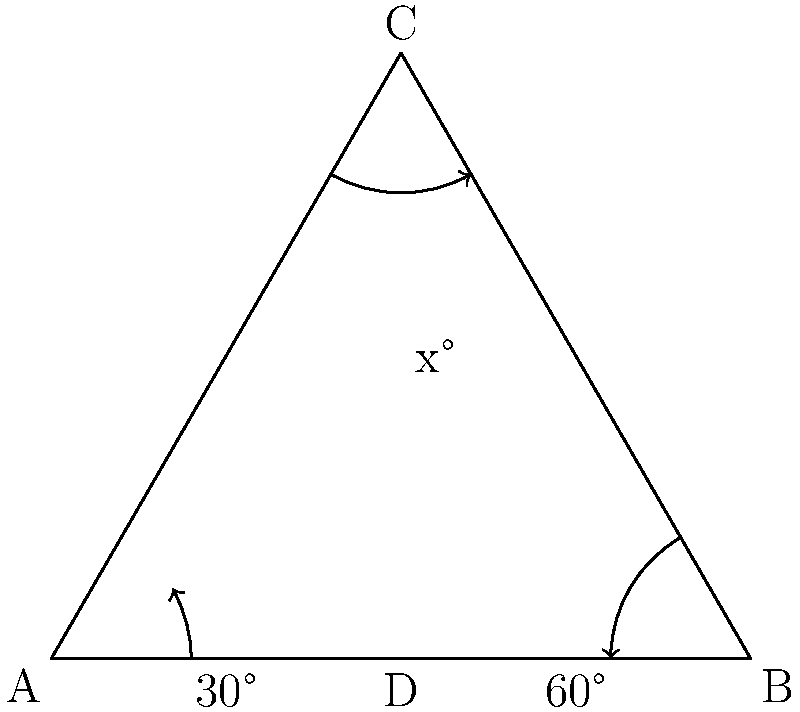During a high-profile international summit in Equatorial Guinea, three diplomatic flights are approaching the capital city from different directions. Their flight paths intersect to form an equilateral triangle, as shown in the diagram. If the angles at the base of the triangle are 30° and 60°, what is the measure of angle x at the apex of the triangle? Let's approach this step-by-step:

1) First, recall that the sum of angles in a triangle is always 180°.

2) In an equilateral triangle, all angles are equal and measure 60°. This is important to keep in mind.

3) In the given triangle, we can see that the base angles are split into 30° and 60°.

4) Let's focus on the left side of the triangle. We know that the angle at A is 30°, and the angle at C (which we're trying to find) is x°.

5) The third angle in this left sub-triangle must be 60° because:
   $30° + x° + 60° = 180°$ (sum of angles in a triangle)

6) Now, let's set up an equation:
   $x° + 30° = 60°$

7) Solving for x:
   $x° = 60° - 30° = 30°$

Therefore, the measure of angle x at the apex of the triangle is 30°.
Answer: 30° 